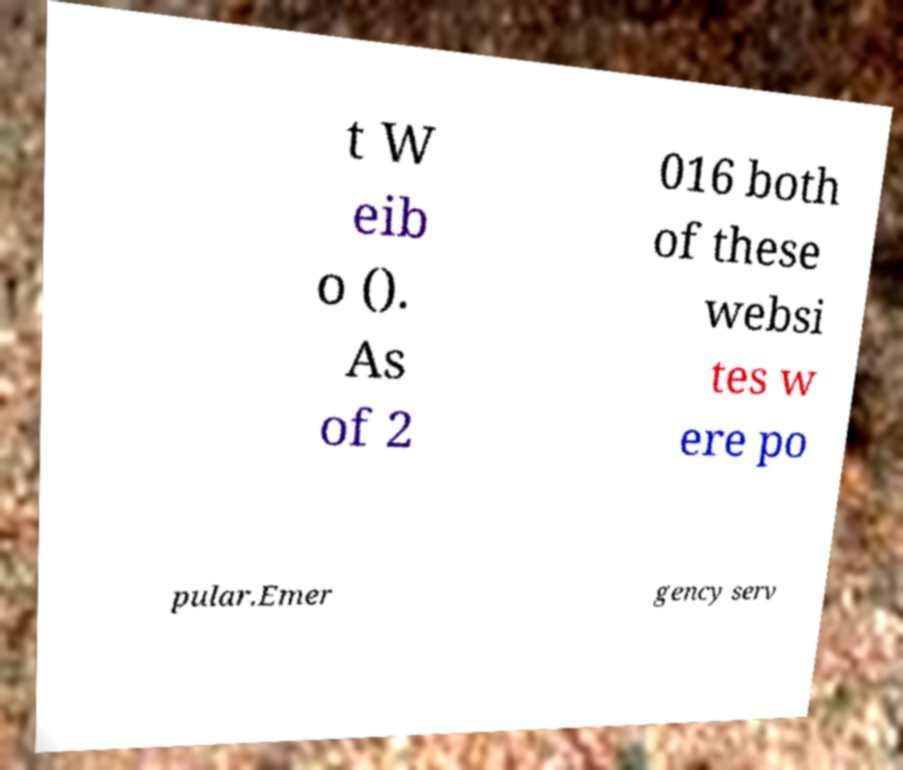For documentation purposes, I need the text within this image transcribed. Could you provide that? t W eib o (). As of 2 016 both of these websi tes w ere po pular.Emer gency serv 